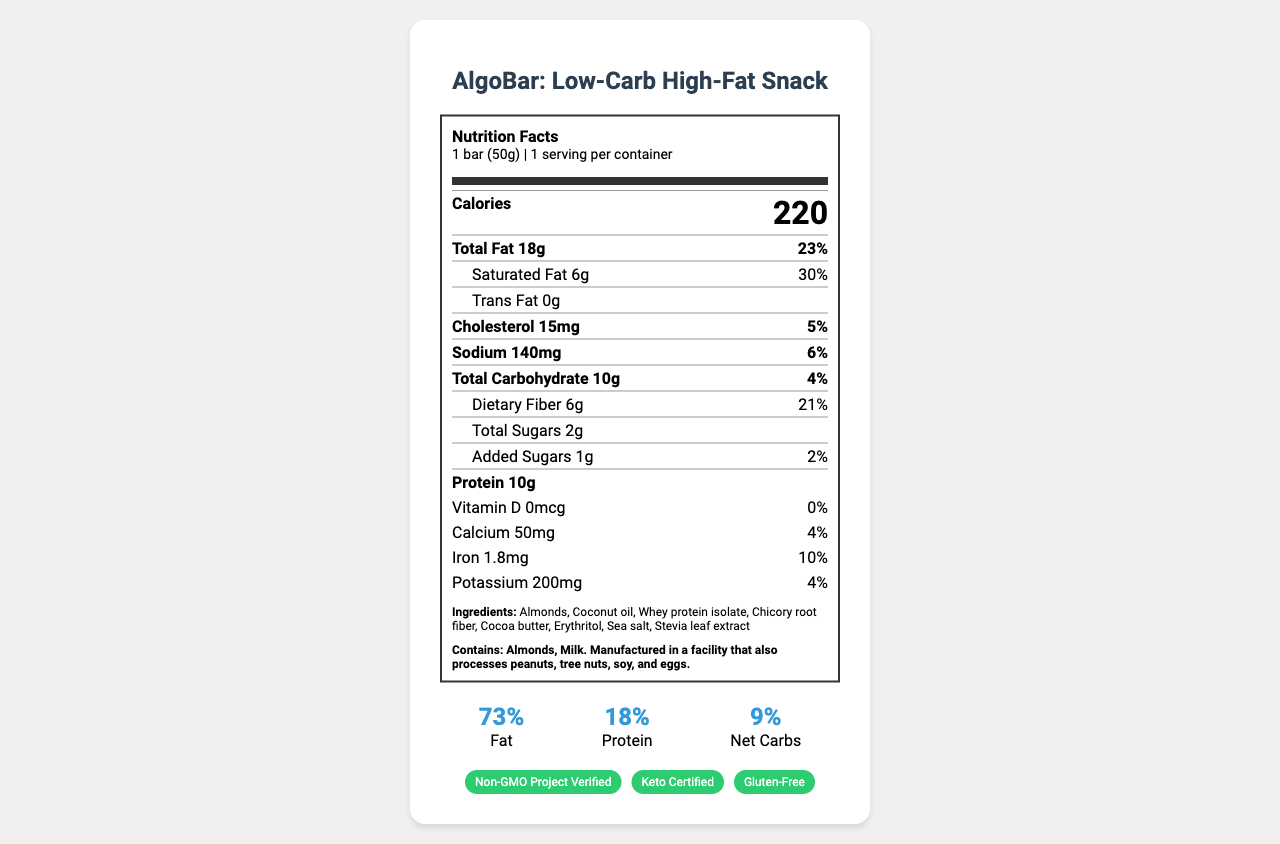what is the serving size of AlgoBar? The serving size is specified at the beginning of the document under the Nutrition Facts section.
Answer: 1 bar (50g) how many calories are there per serving? The number of calories per serving is listed prominently under the Nutrition Facts header as "Calories 220".
Answer: 220 what is the total fat content per serving? The total fat content is listed as "Total Fat 18g" under the Calories information.
Answer: 18g how much saturated fat is in the bar? The saturated fat content is specified as "Saturated Fat 6g" under the Total Fat section.
Answer: 6g what is the dietary fiber content per serving? The dietary fiber content is listed as "Dietary Fiber 6g" under the Total Carbohydrate section.
Answer: 6g which of the following ingredients is not listed in AlgoBar? A. Almonds B. Peanuts C. Erythritol D. Coconut Oil Peanuts are not listed as an ingredient, while Almonds, Erythritol, and Coconut Oil are.
Answer: B how much protein does each serving contain? A. 5g B. 10g C. 15g D. 20g The protein content is listed as 10g per serving under the Protein section.
Answer: B does AlgoBar contain vitamin D? The Vitamin D content is listed as "0mcg" with a daily value of "0%", indicating no Vitamin D.
Answer: No is AlgoBar suitable for someone following a gluten-free diet? The document lists "Gluten-Free" under the certifications section.
Answer: Yes what are the macronutrient ratios for AlgoBar? The macronutrient ratios are clearly specified in the macro-ratios section: Fat 73%, Protein 18%, Net Carbs 9%.
Answer: Fat: 73%, Protein: 18%, Net Carbs: 9% what is the main idea of this document? The document showcases the nutritional facts, ingredients, allergens, macro ratios, and certifications for the product, AlgoBar, highlighting its low-carb and high-fat content.
Answer: It provides the nutritional information, ingredients, and certifications of AlgoBar, a low-carb, high-fat snack bar. what is the barcode number for AlgoBar? The barcode number is listed at the end of the document as "Barcode Number: 1234567890123".
Answer: 1234567890123 how much calcium is in AlgoBar? The calcium content is specified in the Vitamins section as "Calcium 50mg".
Answer: 50mg who is the manufacturer of AlgoBar? The manufacturer information is listed towards the end of the document: "Developed by CodeNutrition Labs, 123 Algorithm Avenue, Silicon Valley, CA 94000".
Answer: CodeNutrition Labs how many grams of added sugars does AlgoBar contain? The added sugars content is listed as "Added Sugars 1g" under the carbohydrate section.
Answer: 1g when should AlgoBar be consumed for best quality? The storage instructions specify that the product should be consumed within 6 months of the production date for the best quality.
Answer: Within 6 months of production date are peanuts processed in the same facility where AlgoBar is made? The allergen information states that the product is manufactured in a facility that also processes peanuts, among other allergens.
Answer: Yes what is the net carb content of AlgoBar? The macro-ratios section specifies the net carbs as 9%.
Answer: Net Carbs: 9% how much potassium is present in the bar? The potassium content is listed under the vitamins as "Potassium 200mg".
Answer: 200mg what is the website for more information about AlgoBar? The website URL for more information is provided at the end of the document: "www.algobar.tech".
Answer: www.algobar.tech what is the production date of the bar? The production date is not provided in the document, so this information is not available.
Answer: Not enough information 